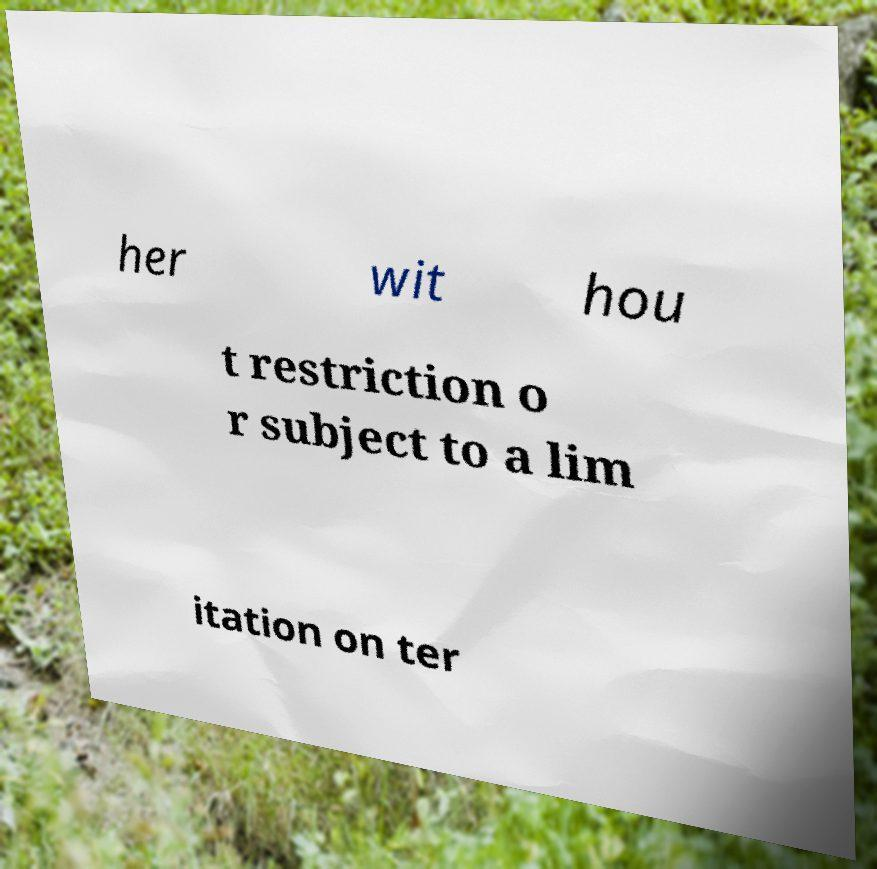What messages or text are displayed in this image? I need them in a readable, typed format. her wit hou t restriction o r subject to a lim itation on ter 